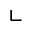Convert formula to latex. <formula><loc_0><loc_0><loc_500><loc_500>\llcorner</formula> 